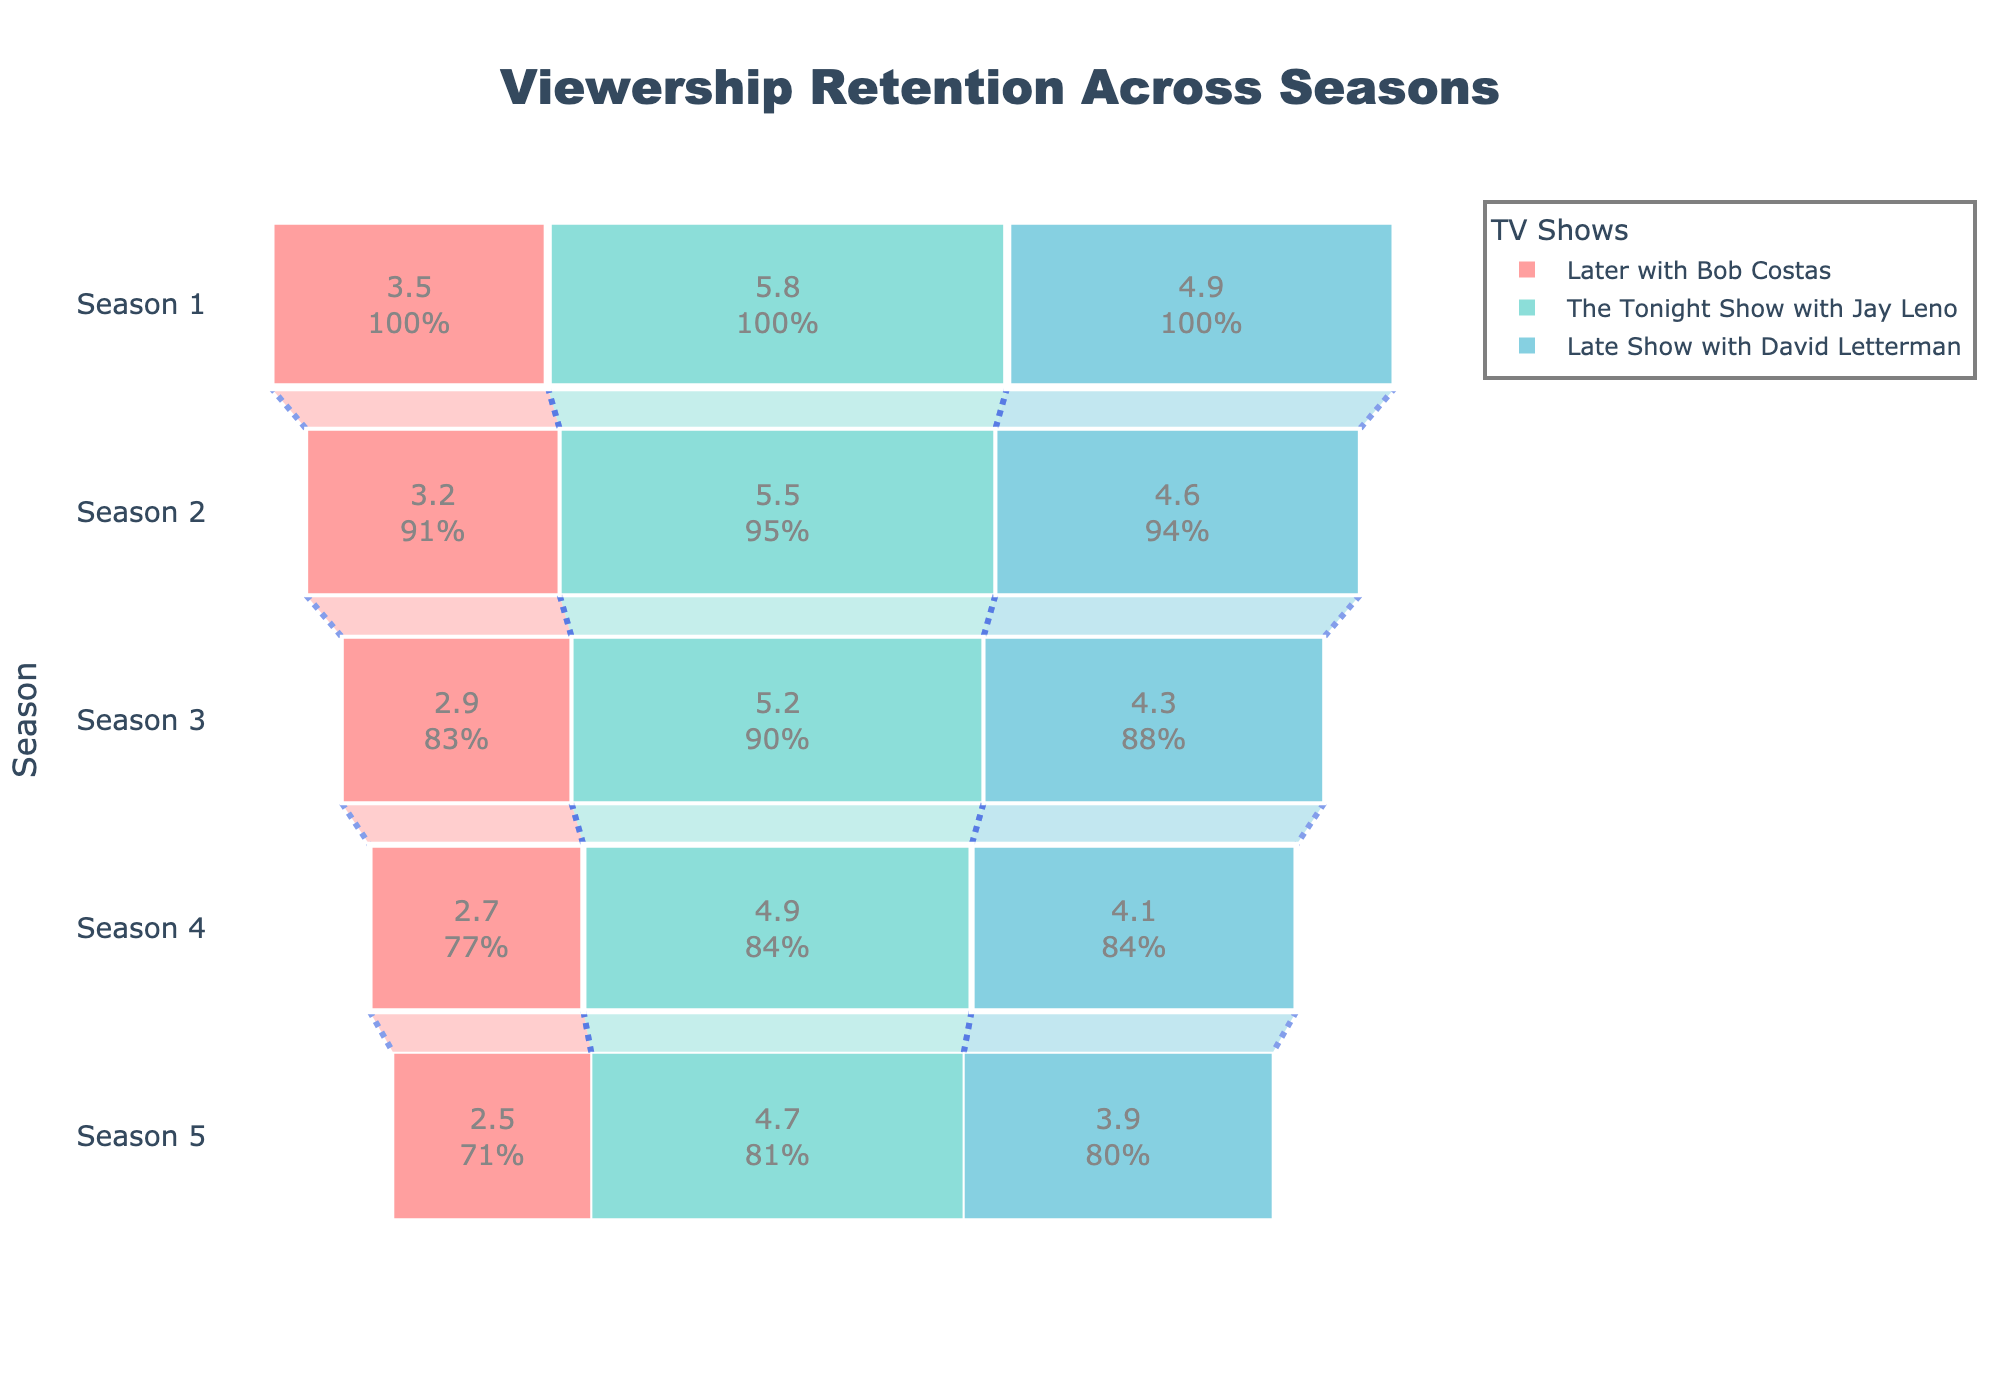How many seasons of "Later with Bob Costas" are depicted in the funnel chart? Count the number of unique seasons listed under "Later with Bob Costas".
Answer: 5 In which season did "The Tonight Show with Jay Leno" have the highest average viewers? Compare the average viewers across all seasons for "The Tonight Show with Jay Leno" and identify the highest value.
Answer: Season 1 What is the color representing "Late Show with David Letterman"? Identify the color used in the funnel chart for "Late Show with David Letterman".
Answer: Blue-green Between Season 3 and Season 5, how much did the average viewership decline for "Later with Bob Costas"? Subtract the average viewers of Season 5 from that of Season 3 for "Later with Bob Costas" (2.9 - 2.5).
Answer: 0.4 million Which show experienced the largest decline in viewership from Season 1 to Season 5? Calculate the decline for each show from Season 1 to Season 5 and determine the largest. ("Later with Bob Costas": 3.5 - 2.5, "The Tonight Show with Jay Leno": 5.8 - 4.7, "Late Show with David Letterman": 4.9 - 3.9)
Answer: The Tonight Show with Jay Leno How does the viewership retention pattern of "Later with Bob Costas" compare to "Late Show with David Letterman"? Review the decline in viewership for both shows across the seasons and compare them. Both shows have a consistent decline, but the amount of decline is different.
Answer: Consistent decline, with "Later with Bob Costas" having a smaller absolute decline compared to "Late Show with David Letterman" Which show maintained the highest average viewership in Season 4? Compare the average viewership for Season 4 across all shows and identify the highest value.
Answer: The Tonight Show with Jay Leno What is the initial viewership percentage retention from Season 1 to Season 2 for "Later with Bob Costas"? Calculate the viewership retention percentage for "Later with Bob Costas" from Season 1 to Season 2: (Season 2 viewership / Season 1 viewership) * 100. (3.2 / 3.5) * 100
Answer: 91.4% By how much did the average viewership differ between "Later with Bob Costas" and "The Tonight Show with Jay Leno" in Season 1? Subtract the average viewers of "Later with Bob Costas" from "The Tonight Show with Jay Leno" for Season 1 (5.8 - 3.5).
Answer: 2.3 million 